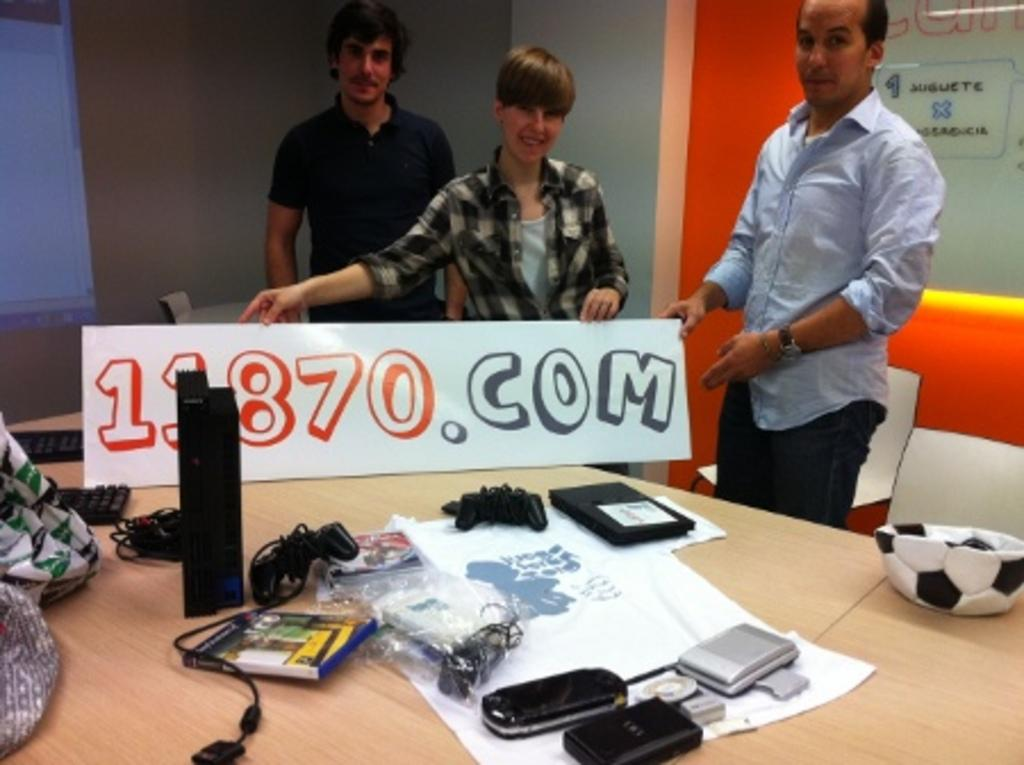How many people are standing behind the table in the image? There are three persons standing behind the table in the image. What items can be seen on the table? There are books, wires, devices, a ball, a bag, and keyboards on the table. What is located at the back of the image? There is a screen at the back of the image. Can you tell me how many spoons are visible in the image? There are no spoons present in the image. Is there a skateboard being used by any of the persons in the image? There is no skateboard visible in the image, and none of the persons are using one. 